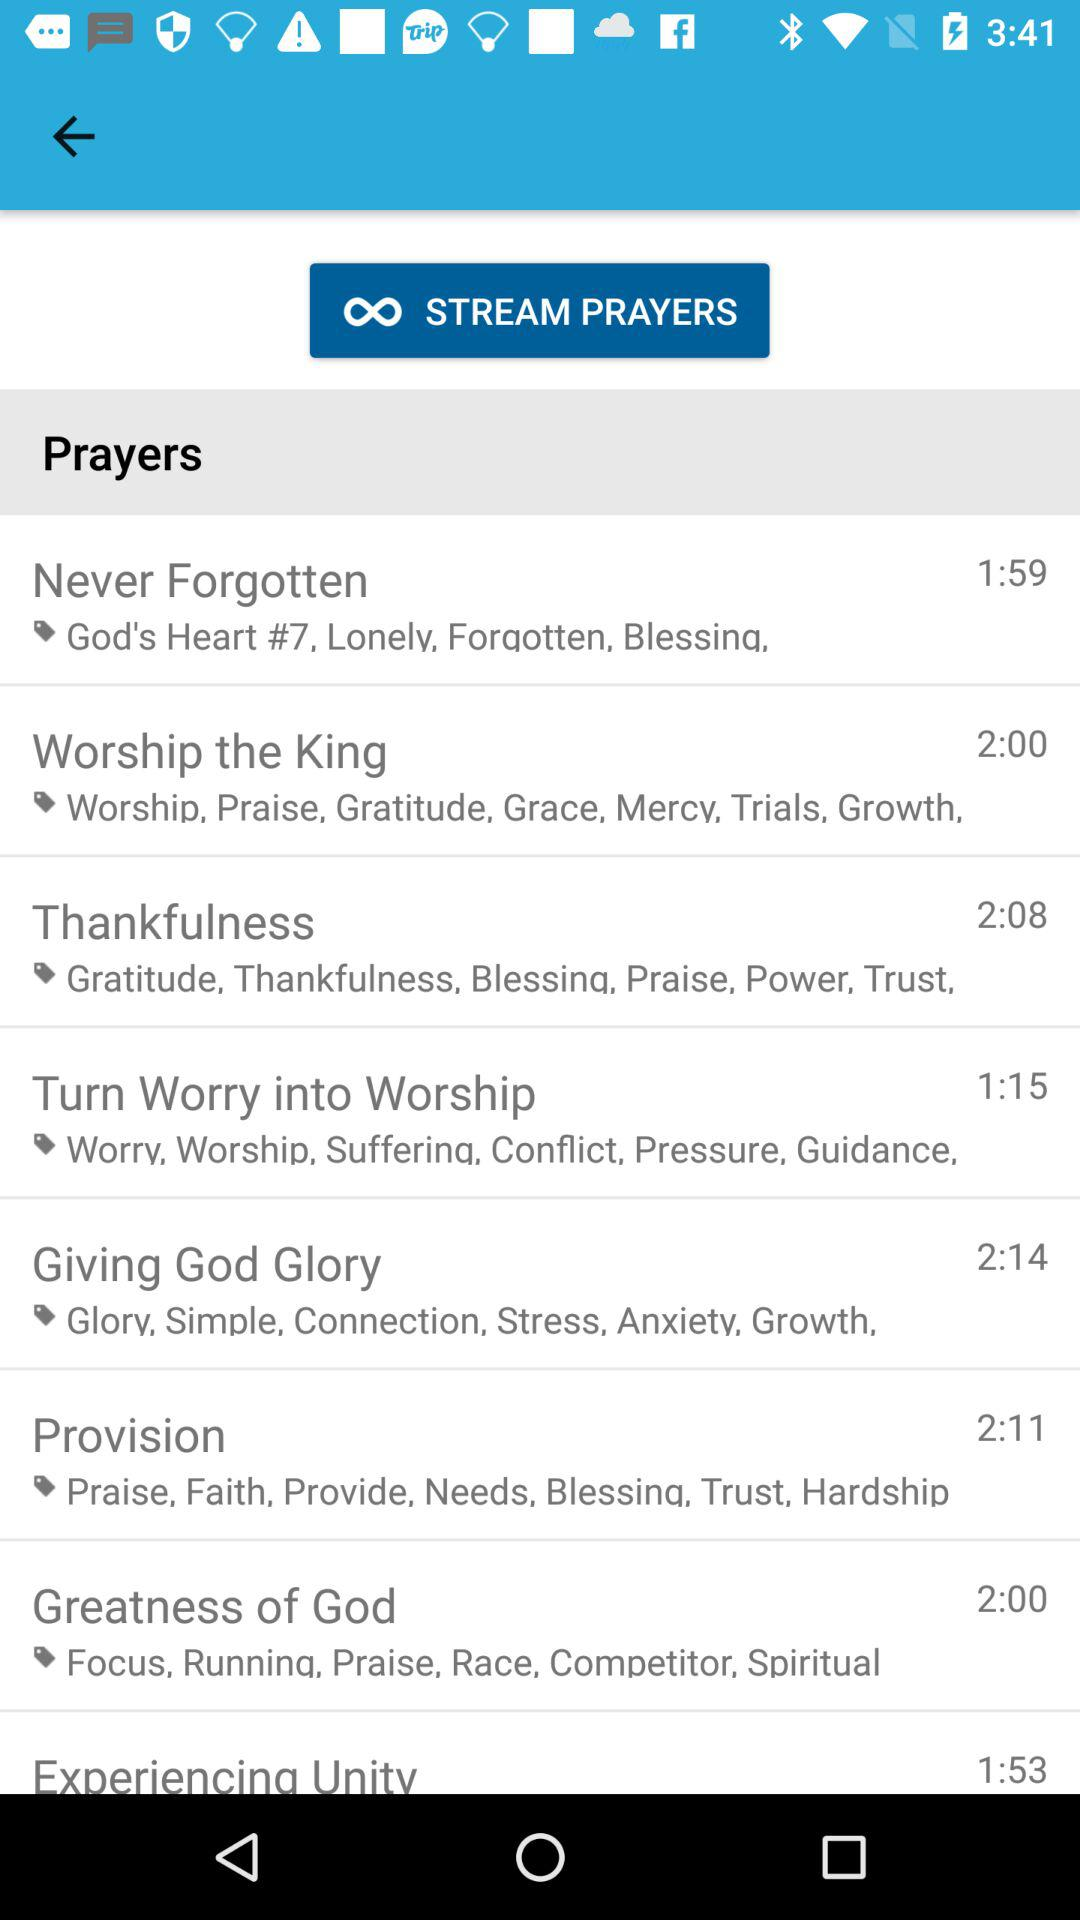How long does the "Never Forgotten" prayer last? The "Never Forgotten" prayer lasts for 1 minute and 59 seconds. 